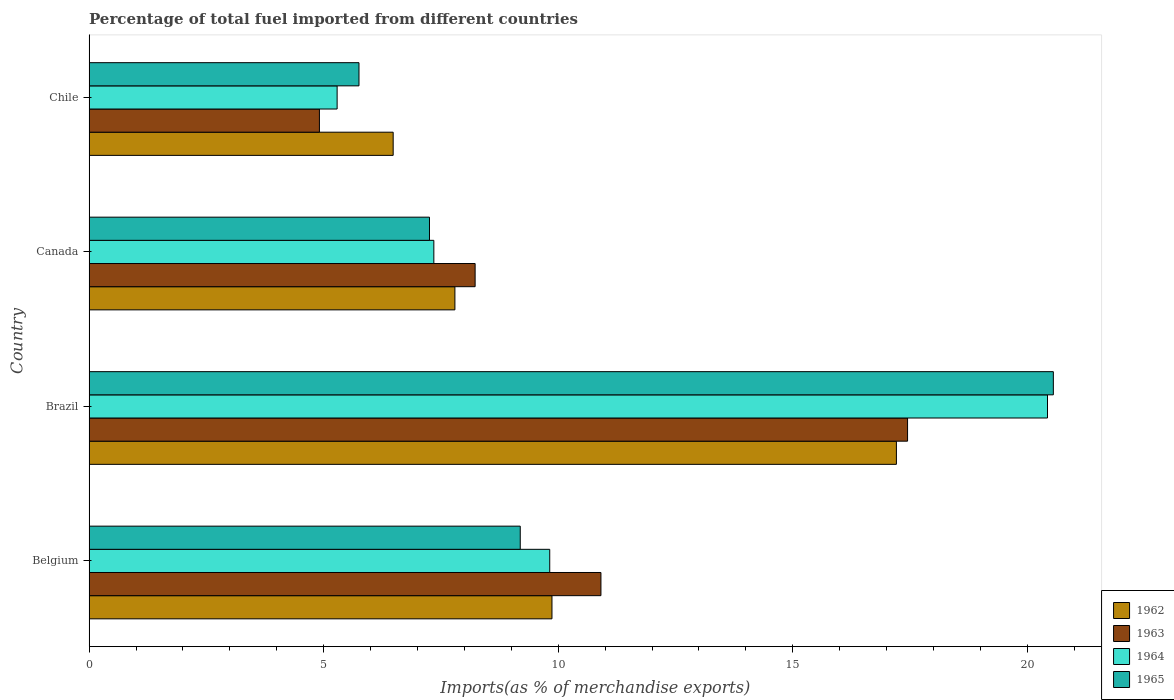How many groups of bars are there?
Provide a short and direct response. 4. Are the number of bars per tick equal to the number of legend labels?
Give a very brief answer. Yes. How many bars are there on the 1st tick from the top?
Give a very brief answer. 4. What is the label of the 1st group of bars from the top?
Offer a very short reply. Chile. In how many cases, is the number of bars for a given country not equal to the number of legend labels?
Offer a terse response. 0. What is the percentage of imports to different countries in 1965 in Chile?
Your response must be concise. 5.75. Across all countries, what is the maximum percentage of imports to different countries in 1962?
Provide a short and direct response. 17.21. Across all countries, what is the minimum percentage of imports to different countries in 1963?
Provide a short and direct response. 4.91. In which country was the percentage of imports to different countries in 1965 maximum?
Give a very brief answer. Brazil. In which country was the percentage of imports to different countries in 1964 minimum?
Offer a very short reply. Chile. What is the total percentage of imports to different countries in 1965 in the graph?
Provide a short and direct response. 42.75. What is the difference between the percentage of imports to different countries in 1965 in Belgium and that in Brazil?
Give a very brief answer. -11.36. What is the difference between the percentage of imports to different countries in 1962 in Chile and the percentage of imports to different countries in 1964 in Canada?
Offer a very short reply. -0.87. What is the average percentage of imports to different countries in 1963 per country?
Make the answer very short. 10.37. What is the difference between the percentage of imports to different countries in 1964 and percentage of imports to different countries in 1962 in Brazil?
Offer a terse response. 3.22. What is the ratio of the percentage of imports to different countries in 1962 in Belgium to that in Brazil?
Give a very brief answer. 0.57. Is the difference between the percentage of imports to different countries in 1964 in Brazil and Chile greater than the difference between the percentage of imports to different countries in 1962 in Brazil and Chile?
Your response must be concise. Yes. What is the difference between the highest and the second highest percentage of imports to different countries in 1963?
Provide a succinct answer. 6.54. What is the difference between the highest and the lowest percentage of imports to different countries in 1965?
Keep it short and to the point. 14.8. In how many countries, is the percentage of imports to different countries in 1965 greater than the average percentage of imports to different countries in 1965 taken over all countries?
Your response must be concise. 1. Is it the case that in every country, the sum of the percentage of imports to different countries in 1965 and percentage of imports to different countries in 1963 is greater than the sum of percentage of imports to different countries in 1962 and percentage of imports to different countries in 1964?
Provide a succinct answer. No. What does the 1st bar from the top in Canada represents?
Your response must be concise. 1965. What does the 4th bar from the bottom in Chile represents?
Provide a short and direct response. 1965. How many bars are there?
Your response must be concise. 16. Are the values on the major ticks of X-axis written in scientific E-notation?
Provide a short and direct response. No. Does the graph contain any zero values?
Give a very brief answer. No. What is the title of the graph?
Make the answer very short. Percentage of total fuel imported from different countries. Does "1979" appear as one of the legend labels in the graph?
Make the answer very short. No. What is the label or title of the X-axis?
Provide a short and direct response. Imports(as % of merchandise exports). What is the Imports(as % of merchandise exports) of 1962 in Belgium?
Give a very brief answer. 9.87. What is the Imports(as % of merchandise exports) of 1963 in Belgium?
Keep it short and to the point. 10.91. What is the Imports(as % of merchandise exports) in 1964 in Belgium?
Offer a terse response. 9.82. What is the Imports(as % of merchandise exports) in 1965 in Belgium?
Your response must be concise. 9.19. What is the Imports(as % of merchandise exports) in 1962 in Brazil?
Ensure brevity in your answer.  17.21. What is the Imports(as % of merchandise exports) in 1963 in Brazil?
Offer a terse response. 17.45. What is the Imports(as % of merchandise exports) in 1964 in Brazil?
Provide a succinct answer. 20.43. What is the Imports(as % of merchandise exports) in 1965 in Brazil?
Keep it short and to the point. 20.55. What is the Imports(as % of merchandise exports) of 1962 in Canada?
Your response must be concise. 7.8. What is the Imports(as % of merchandise exports) in 1963 in Canada?
Make the answer very short. 8.23. What is the Imports(as % of merchandise exports) of 1964 in Canada?
Keep it short and to the point. 7.35. What is the Imports(as % of merchandise exports) of 1965 in Canada?
Your answer should be very brief. 7.26. What is the Imports(as % of merchandise exports) in 1962 in Chile?
Your answer should be very brief. 6.48. What is the Imports(as % of merchandise exports) of 1963 in Chile?
Ensure brevity in your answer.  4.91. What is the Imports(as % of merchandise exports) in 1964 in Chile?
Offer a terse response. 5.29. What is the Imports(as % of merchandise exports) in 1965 in Chile?
Ensure brevity in your answer.  5.75. Across all countries, what is the maximum Imports(as % of merchandise exports) of 1962?
Your response must be concise. 17.21. Across all countries, what is the maximum Imports(as % of merchandise exports) in 1963?
Provide a succinct answer. 17.45. Across all countries, what is the maximum Imports(as % of merchandise exports) of 1964?
Make the answer very short. 20.43. Across all countries, what is the maximum Imports(as % of merchandise exports) in 1965?
Give a very brief answer. 20.55. Across all countries, what is the minimum Imports(as % of merchandise exports) in 1962?
Your response must be concise. 6.48. Across all countries, what is the minimum Imports(as % of merchandise exports) in 1963?
Provide a succinct answer. 4.91. Across all countries, what is the minimum Imports(as % of merchandise exports) in 1964?
Provide a succinct answer. 5.29. Across all countries, what is the minimum Imports(as % of merchandise exports) of 1965?
Provide a short and direct response. 5.75. What is the total Imports(as % of merchandise exports) in 1962 in the graph?
Provide a succinct answer. 41.36. What is the total Imports(as % of merchandise exports) in 1963 in the graph?
Offer a very short reply. 41.5. What is the total Imports(as % of merchandise exports) of 1964 in the graph?
Offer a very short reply. 42.88. What is the total Imports(as % of merchandise exports) in 1965 in the graph?
Offer a very short reply. 42.75. What is the difference between the Imports(as % of merchandise exports) in 1962 in Belgium and that in Brazil?
Your answer should be compact. -7.34. What is the difference between the Imports(as % of merchandise exports) of 1963 in Belgium and that in Brazil?
Make the answer very short. -6.54. What is the difference between the Imports(as % of merchandise exports) of 1964 in Belgium and that in Brazil?
Give a very brief answer. -10.61. What is the difference between the Imports(as % of merchandise exports) in 1965 in Belgium and that in Brazil?
Offer a terse response. -11.36. What is the difference between the Imports(as % of merchandise exports) in 1962 in Belgium and that in Canada?
Make the answer very short. 2.07. What is the difference between the Imports(as % of merchandise exports) of 1963 in Belgium and that in Canada?
Offer a terse response. 2.68. What is the difference between the Imports(as % of merchandise exports) of 1964 in Belgium and that in Canada?
Give a very brief answer. 2.47. What is the difference between the Imports(as % of merchandise exports) of 1965 in Belgium and that in Canada?
Your answer should be compact. 1.93. What is the difference between the Imports(as % of merchandise exports) of 1962 in Belgium and that in Chile?
Keep it short and to the point. 3.39. What is the difference between the Imports(as % of merchandise exports) of 1963 in Belgium and that in Chile?
Your answer should be compact. 6. What is the difference between the Imports(as % of merchandise exports) of 1964 in Belgium and that in Chile?
Provide a succinct answer. 4.53. What is the difference between the Imports(as % of merchandise exports) in 1965 in Belgium and that in Chile?
Ensure brevity in your answer.  3.44. What is the difference between the Imports(as % of merchandise exports) of 1962 in Brazil and that in Canada?
Keep it short and to the point. 9.41. What is the difference between the Imports(as % of merchandise exports) of 1963 in Brazil and that in Canada?
Your response must be concise. 9.22. What is the difference between the Imports(as % of merchandise exports) of 1964 in Brazil and that in Canada?
Keep it short and to the point. 13.08. What is the difference between the Imports(as % of merchandise exports) in 1965 in Brazil and that in Canada?
Offer a very short reply. 13.3. What is the difference between the Imports(as % of merchandise exports) of 1962 in Brazil and that in Chile?
Your response must be concise. 10.73. What is the difference between the Imports(as % of merchandise exports) in 1963 in Brazil and that in Chile?
Ensure brevity in your answer.  12.54. What is the difference between the Imports(as % of merchandise exports) of 1964 in Brazil and that in Chile?
Your response must be concise. 15.14. What is the difference between the Imports(as % of merchandise exports) in 1965 in Brazil and that in Chile?
Keep it short and to the point. 14.8. What is the difference between the Imports(as % of merchandise exports) in 1962 in Canada and that in Chile?
Offer a terse response. 1.32. What is the difference between the Imports(as % of merchandise exports) in 1963 in Canada and that in Chile?
Keep it short and to the point. 3.32. What is the difference between the Imports(as % of merchandise exports) of 1964 in Canada and that in Chile?
Your answer should be very brief. 2.06. What is the difference between the Imports(as % of merchandise exports) of 1965 in Canada and that in Chile?
Provide a succinct answer. 1.5. What is the difference between the Imports(as % of merchandise exports) in 1962 in Belgium and the Imports(as % of merchandise exports) in 1963 in Brazil?
Offer a terse response. -7.58. What is the difference between the Imports(as % of merchandise exports) of 1962 in Belgium and the Imports(as % of merchandise exports) of 1964 in Brazil?
Offer a terse response. -10.56. What is the difference between the Imports(as % of merchandise exports) of 1962 in Belgium and the Imports(as % of merchandise exports) of 1965 in Brazil?
Provide a succinct answer. -10.69. What is the difference between the Imports(as % of merchandise exports) of 1963 in Belgium and the Imports(as % of merchandise exports) of 1964 in Brazil?
Make the answer very short. -9.52. What is the difference between the Imports(as % of merchandise exports) of 1963 in Belgium and the Imports(as % of merchandise exports) of 1965 in Brazil?
Your response must be concise. -9.64. What is the difference between the Imports(as % of merchandise exports) in 1964 in Belgium and the Imports(as % of merchandise exports) in 1965 in Brazil?
Provide a short and direct response. -10.74. What is the difference between the Imports(as % of merchandise exports) in 1962 in Belgium and the Imports(as % of merchandise exports) in 1963 in Canada?
Make the answer very short. 1.64. What is the difference between the Imports(as % of merchandise exports) in 1962 in Belgium and the Imports(as % of merchandise exports) in 1964 in Canada?
Offer a very short reply. 2.52. What is the difference between the Imports(as % of merchandise exports) of 1962 in Belgium and the Imports(as % of merchandise exports) of 1965 in Canada?
Make the answer very short. 2.61. What is the difference between the Imports(as % of merchandise exports) in 1963 in Belgium and the Imports(as % of merchandise exports) in 1964 in Canada?
Your response must be concise. 3.56. What is the difference between the Imports(as % of merchandise exports) of 1963 in Belgium and the Imports(as % of merchandise exports) of 1965 in Canada?
Ensure brevity in your answer.  3.65. What is the difference between the Imports(as % of merchandise exports) in 1964 in Belgium and the Imports(as % of merchandise exports) in 1965 in Canada?
Make the answer very short. 2.56. What is the difference between the Imports(as % of merchandise exports) in 1962 in Belgium and the Imports(as % of merchandise exports) in 1963 in Chile?
Offer a terse response. 4.96. What is the difference between the Imports(as % of merchandise exports) in 1962 in Belgium and the Imports(as % of merchandise exports) in 1964 in Chile?
Offer a terse response. 4.58. What is the difference between the Imports(as % of merchandise exports) of 1962 in Belgium and the Imports(as % of merchandise exports) of 1965 in Chile?
Keep it short and to the point. 4.11. What is the difference between the Imports(as % of merchandise exports) in 1963 in Belgium and the Imports(as % of merchandise exports) in 1964 in Chile?
Offer a terse response. 5.62. What is the difference between the Imports(as % of merchandise exports) in 1963 in Belgium and the Imports(as % of merchandise exports) in 1965 in Chile?
Your response must be concise. 5.16. What is the difference between the Imports(as % of merchandise exports) of 1964 in Belgium and the Imports(as % of merchandise exports) of 1965 in Chile?
Ensure brevity in your answer.  4.07. What is the difference between the Imports(as % of merchandise exports) in 1962 in Brazil and the Imports(as % of merchandise exports) in 1963 in Canada?
Keep it short and to the point. 8.98. What is the difference between the Imports(as % of merchandise exports) of 1962 in Brazil and the Imports(as % of merchandise exports) of 1964 in Canada?
Make the answer very short. 9.86. What is the difference between the Imports(as % of merchandise exports) in 1962 in Brazil and the Imports(as % of merchandise exports) in 1965 in Canada?
Keep it short and to the point. 9.95. What is the difference between the Imports(as % of merchandise exports) in 1963 in Brazil and the Imports(as % of merchandise exports) in 1964 in Canada?
Provide a succinct answer. 10.1. What is the difference between the Imports(as % of merchandise exports) in 1963 in Brazil and the Imports(as % of merchandise exports) in 1965 in Canada?
Provide a succinct answer. 10.19. What is the difference between the Imports(as % of merchandise exports) in 1964 in Brazil and the Imports(as % of merchandise exports) in 1965 in Canada?
Provide a short and direct response. 13.17. What is the difference between the Imports(as % of merchandise exports) in 1962 in Brazil and the Imports(as % of merchandise exports) in 1963 in Chile?
Provide a short and direct response. 12.3. What is the difference between the Imports(as % of merchandise exports) in 1962 in Brazil and the Imports(as % of merchandise exports) in 1964 in Chile?
Make the answer very short. 11.92. What is the difference between the Imports(as % of merchandise exports) in 1962 in Brazil and the Imports(as % of merchandise exports) in 1965 in Chile?
Your answer should be very brief. 11.46. What is the difference between the Imports(as % of merchandise exports) in 1963 in Brazil and the Imports(as % of merchandise exports) in 1964 in Chile?
Offer a terse response. 12.16. What is the difference between the Imports(as % of merchandise exports) of 1963 in Brazil and the Imports(as % of merchandise exports) of 1965 in Chile?
Keep it short and to the point. 11.69. What is the difference between the Imports(as % of merchandise exports) of 1964 in Brazil and the Imports(as % of merchandise exports) of 1965 in Chile?
Your response must be concise. 14.68. What is the difference between the Imports(as % of merchandise exports) in 1962 in Canada and the Imports(as % of merchandise exports) in 1963 in Chile?
Your answer should be compact. 2.89. What is the difference between the Imports(as % of merchandise exports) in 1962 in Canada and the Imports(as % of merchandise exports) in 1964 in Chile?
Offer a very short reply. 2.51. What is the difference between the Imports(as % of merchandise exports) of 1962 in Canada and the Imports(as % of merchandise exports) of 1965 in Chile?
Ensure brevity in your answer.  2.04. What is the difference between the Imports(as % of merchandise exports) of 1963 in Canada and the Imports(as % of merchandise exports) of 1964 in Chile?
Provide a succinct answer. 2.94. What is the difference between the Imports(as % of merchandise exports) in 1963 in Canada and the Imports(as % of merchandise exports) in 1965 in Chile?
Make the answer very short. 2.48. What is the difference between the Imports(as % of merchandise exports) of 1964 in Canada and the Imports(as % of merchandise exports) of 1965 in Chile?
Make the answer very short. 1.6. What is the average Imports(as % of merchandise exports) in 1962 per country?
Offer a very short reply. 10.34. What is the average Imports(as % of merchandise exports) of 1963 per country?
Ensure brevity in your answer.  10.37. What is the average Imports(as % of merchandise exports) of 1964 per country?
Offer a very short reply. 10.72. What is the average Imports(as % of merchandise exports) of 1965 per country?
Offer a terse response. 10.69. What is the difference between the Imports(as % of merchandise exports) of 1962 and Imports(as % of merchandise exports) of 1963 in Belgium?
Offer a terse response. -1.04. What is the difference between the Imports(as % of merchandise exports) of 1962 and Imports(as % of merchandise exports) of 1964 in Belgium?
Your response must be concise. 0.05. What is the difference between the Imports(as % of merchandise exports) of 1962 and Imports(as % of merchandise exports) of 1965 in Belgium?
Provide a short and direct response. 0.68. What is the difference between the Imports(as % of merchandise exports) of 1963 and Imports(as % of merchandise exports) of 1964 in Belgium?
Provide a succinct answer. 1.09. What is the difference between the Imports(as % of merchandise exports) of 1963 and Imports(as % of merchandise exports) of 1965 in Belgium?
Keep it short and to the point. 1.72. What is the difference between the Imports(as % of merchandise exports) in 1964 and Imports(as % of merchandise exports) in 1965 in Belgium?
Your response must be concise. 0.63. What is the difference between the Imports(as % of merchandise exports) of 1962 and Imports(as % of merchandise exports) of 1963 in Brazil?
Offer a terse response. -0.24. What is the difference between the Imports(as % of merchandise exports) of 1962 and Imports(as % of merchandise exports) of 1964 in Brazil?
Your response must be concise. -3.22. What is the difference between the Imports(as % of merchandise exports) in 1962 and Imports(as % of merchandise exports) in 1965 in Brazil?
Provide a short and direct response. -3.35. What is the difference between the Imports(as % of merchandise exports) in 1963 and Imports(as % of merchandise exports) in 1964 in Brazil?
Make the answer very short. -2.98. What is the difference between the Imports(as % of merchandise exports) in 1963 and Imports(as % of merchandise exports) in 1965 in Brazil?
Give a very brief answer. -3.11. What is the difference between the Imports(as % of merchandise exports) in 1964 and Imports(as % of merchandise exports) in 1965 in Brazil?
Give a very brief answer. -0.12. What is the difference between the Imports(as % of merchandise exports) in 1962 and Imports(as % of merchandise exports) in 1963 in Canada?
Your response must be concise. -0.43. What is the difference between the Imports(as % of merchandise exports) of 1962 and Imports(as % of merchandise exports) of 1964 in Canada?
Your response must be concise. 0.45. What is the difference between the Imports(as % of merchandise exports) of 1962 and Imports(as % of merchandise exports) of 1965 in Canada?
Keep it short and to the point. 0.54. What is the difference between the Imports(as % of merchandise exports) of 1963 and Imports(as % of merchandise exports) of 1964 in Canada?
Keep it short and to the point. 0.88. What is the difference between the Imports(as % of merchandise exports) in 1963 and Imports(as % of merchandise exports) in 1965 in Canada?
Give a very brief answer. 0.97. What is the difference between the Imports(as % of merchandise exports) of 1964 and Imports(as % of merchandise exports) of 1965 in Canada?
Ensure brevity in your answer.  0.09. What is the difference between the Imports(as % of merchandise exports) of 1962 and Imports(as % of merchandise exports) of 1963 in Chile?
Give a very brief answer. 1.57. What is the difference between the Imports(as % of merchandise exports) in 1962 and Imports(as % of merchandise exports) in 1964 in Chile?
Your response must be concise. 1.19. What is the difference between the Imports(as % of merchandise exports) of 1962 and Imports(as % of merchandise exports) of 1965 in Chile?
Ensure brevity in your answer.  0.73. What is the difference between the Imports(as % of merchandise exports) in 1963 and Imports(as % of merchandise exports) in 1964 in Chile?
Offer a terse response. -0.38. What is the difference between the Imports(as % of merchandise exports) of 1963 and Imports(as % of merchandise exports) of 1965 in Chile?
Your response must be concise. -0.84. What is the difference between the Imports(as % of merchandise exports) in 1964 and Imports(as % of merchandise exports) in 1965 in Chile?
Your answer should be very brief. -0.47. What is the ratio of the Imports(as % of merchandise exports) in 1962 in Belgium to that in Brazil?
Give a very brief answer. 0.57. What is the ratio of the Imports(as % of merchandise exports) in 1963 in Belgium to that in Brazil?
Offer a terse response. 0.63. What is the ratio of the Imports(as % of merchandise exports) of 1964 in Belgium to that in Brazil?
Your answer should be very brief. 0.48. What is the ratio of the Imports(as % of merchandise exports) of 1965 in Belgium to that in Brazil?
Your answer should be very brief. 0.45. What is the ratio of the Imports(as % of merchandise exports) in 1962 in Belgium to that in Canada?
Provide a succinct answer. 1.27. What is the ratio of the Imports(as % of merchandise exports) in 1963 in Belgium to that in Canada?
Offer a very short reply. 1.33. What is the ratio of the Imports(as % of merchandise exports) in 1964 in Belgium to that in Canada?
Your answer should be very brief. 1.34. What is the ratio of the Imports(as % of merchandise exports) of 1965 in Belgium to that in Canada?
Make the answer very short. 1.27. What is the ratio of the Imports(as % of merchandise exports) in 1962 in Belgium to that in Chile?
Give a very brief answer. 1.52. What is the ratio of the Imports(as % of merchandise exports) of 1963 in Belgium to that in Chile?
Provide a succinct answer. 2.22. What is the ratio of the Imports(as % of merchandise exports) in 1964 in Belgium to that in Chile?
Offer a terse response. 1.86. What is the ratio of the Imports(as % of merchandise exports) of 1965 in Belgium to that in Chile?
Your answer should be compact. 1.6. What is the ratio of the Imports(as % of merchandise exports) of 1962 in Brazil to that in Canada?
Keep it short and to the point. 2.21. What is the ratio of the Imports(as % of merchandise exports) of 1963 in Brazil to that in Canada?
Ensure brevity in your answer.  2.12. What is the ratio of the Imports(as % of merchandise exports) of 1964 in Brazil to that in Canada?
Provide a succinct answer. 2.78. What is the ratio of the Imports(as % of merchandise exports) of 1965 in Brazil to that in Canada?
Offer a very short reply. 2.83. What is the ratio of the Imports(as % of merchandise exports) in 1962 in Brazil to that in Chile?
Offer a very short reply. 2.65. What is the ratio of the Imports(as % of merchandise exports) in 1963 in Brazil to that in Chile?
Give a very brief answer. 3.55. What is the ratio of the Imports(as % of merchandise exports) of 1964 in Brazil to that in Chile?
Your answer should be compact. 3.86. What is the ratio of the Imports(as % of merchandise exports) in 1965 in Brazil to that in Chile?
Provide a succinct answer. 3.57. What is the ratio of the Imports(as % of merchandise exports) in 1962 in Canada to that in Chile?
Provide a short and direct response. 1.2. What is the ratio of the Imports(as % of merchandise exports) in 1963 in Canada to that in Chile?
Offer a very short reply. 1.68. What is the ratio of the Imports(as % of merchandise exports) in 1964 in Canada to that in Chile?
Your answer should be very brief. 1.39. What is the ratio of the Imports(as % of merchandise exports) in 1965 in Canada to that in Chile?
Offer a very short reply. 1.26. What is the difference between the highest and the second highest Imports(as % of merchandise exports) in 1962?
Make the answer very short. 7.34. What is the difference between the highest and the second highest Imports(as % of merchandise exports) in 1963?
Your answer should be very brief. 6.54. What is the difference between the highest and the second highest Imports(as % of merchandise exports) of 1964?
Keep it short and to the point. 10.61. What is the difference between the highest and the second highest Imports(as % of merchandise exports) of 1965?
Your answer should be very brief. 11.36. What is the difference between the highest and the lowest Imports(as % of merchandise exports) in 1962?
Your answer should be very brief. 10.73. What is the difference between the highest and the lowest Imports(as % of merchandise exports) of 1963?
Your response must be concise. 12.54. What is the difference between the highest and the lowest Imports(as % of merchandise exports) of 1964?
Keep it short and to the point. 15.14. What is the difference between the highest and the lowest Imports(as % of merchandise exports) in 1965?
Give a very brief answer. 14.8. 